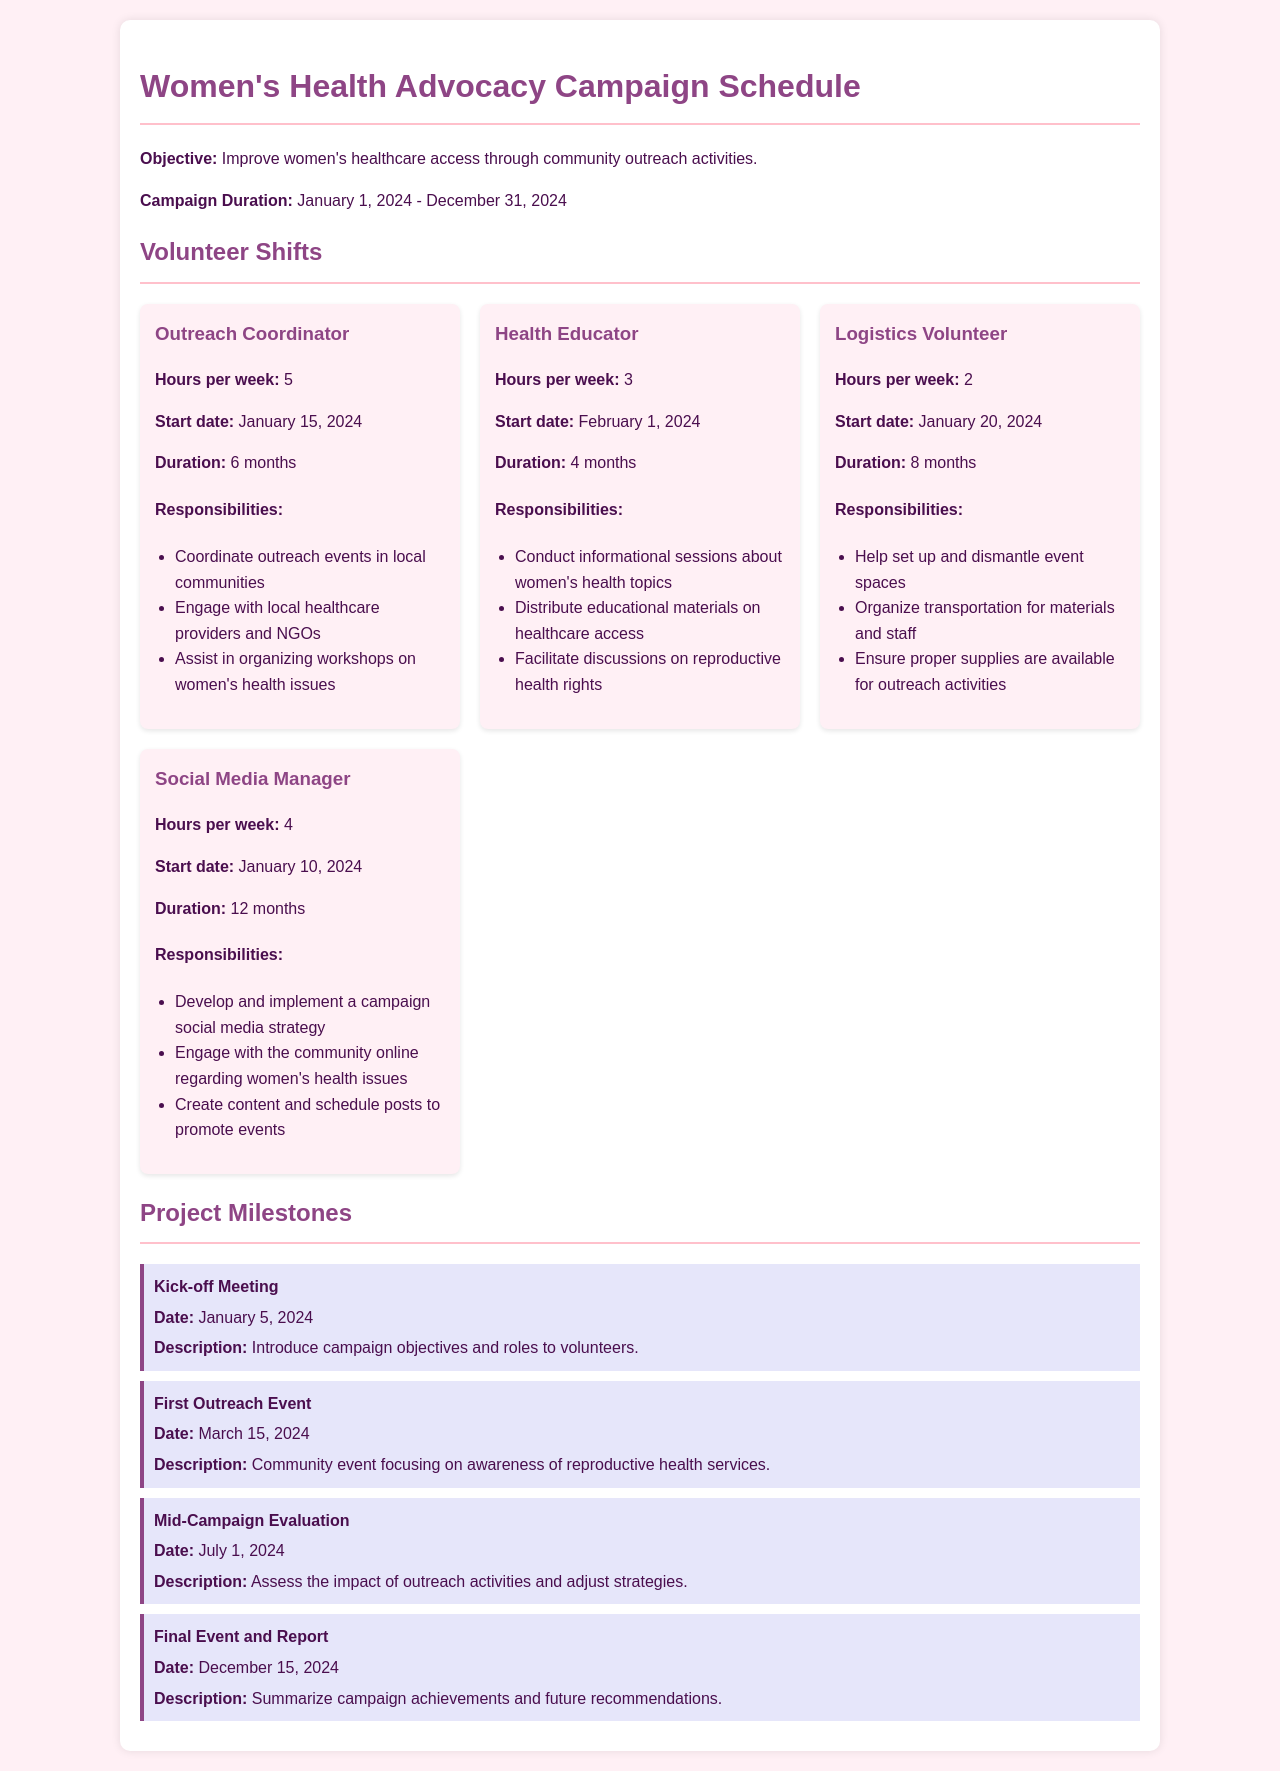what is the campaign duration? The campaign duration is specified in the document as the period from January 1, 2024, to December 31, 2024.
Answer: January 1, 2024 - December 31, 2024 who is the Outreach Coordinator? The document mentions the role of Outreach Coordinator, including responsibilities, but does not specify a person's name.
Answer: Not specified how many hours per week does the Health Educator work? The document states the hours per week for the Health Educator as part of their role details.
Answer: 3 what is the date of the first outreach event? The date for the first outreach event is listed in the project milestones section of the document.
Answer: March 15, 2024 how long is the duration of the Logistics Volunteer role? The document provides the duration for the Logistics Volunteer role in the volunteer shifts section.
Answer: 8 months what is one responsibility of the Social Media Manager? One of the responsibilities listed for the Social Media Manager is to develop and implement a campaign social media strategy.
Answer: Develop and implement a campaign social media strategy when is the mid-campaign evaluation scheduled? The date for the mid-campaign evaluation is mentioned in the project milestones section.
Answer: July 1, 2024 how many total milestones are listed in the document? The document provides a list of milestones, and the total number can be counted from that section.
Answer: 4 what task does the Logistics Volunteer help with? The document describes several responsibilities of the Logistics Volunteer, which includes helping set up and dismantle event spaces.
Answer: Help set up and dismantle event spaces 